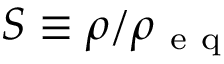Convert formula to latex. <formula><loc_0><loc_0><loc_500><loc_500>S \equiv \rho / \rho _ { e q }</formula> 